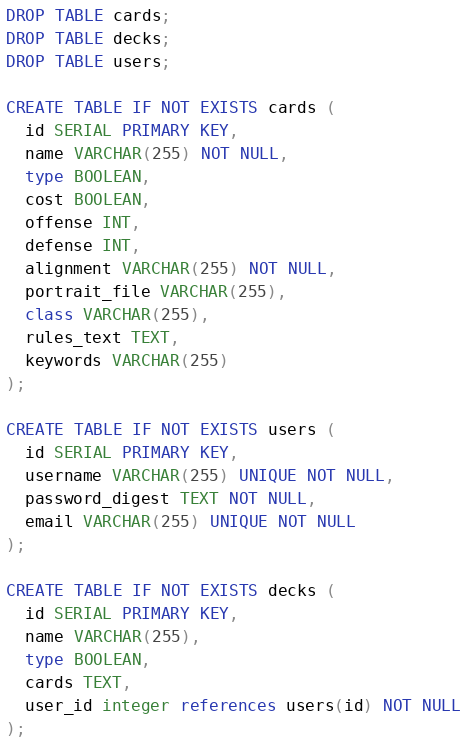Convert code to text. <code><loc_0><loc_0><loc_500><loc_500><_SQL_>DROP TABLE cards;
DROP TABLE decks;
DROP TABLE users;

CREATE TABLE IF NOT EXISTS cards (
  id SERIAL PRIMARY KEY,
  name VARCHAR(255) NOT NULL,
  type BOOLEAN,
  cost BOOLEAN,
  offense INT,
  defense INT,
  alignment VARCHAR(255) NOT NULL,
  portrait_file VARCHAR(255),
  class VARCHAR(255),
  rules_text TEXT,
  keywords VARCHAR(255)
);

CREATE TABLE IF NOT EXISTS users (
  id SERIAL PRIMARY KEY,
  username VARCHAR(255) UNIQUE NOT NULL,
  password_digest TEXT NOT NULL,
  email VARCHAR(255) UNIQUE NOT NULL
);

CREATE TABLE IF NOT EXISTS decks (
  id SERIAL PRIMARY KEY,
  name VARCHAR(255),
  type BOOLEAN,
  cards TEXT,
  user_id integer references users(id) NOT NULL
);
</code> 